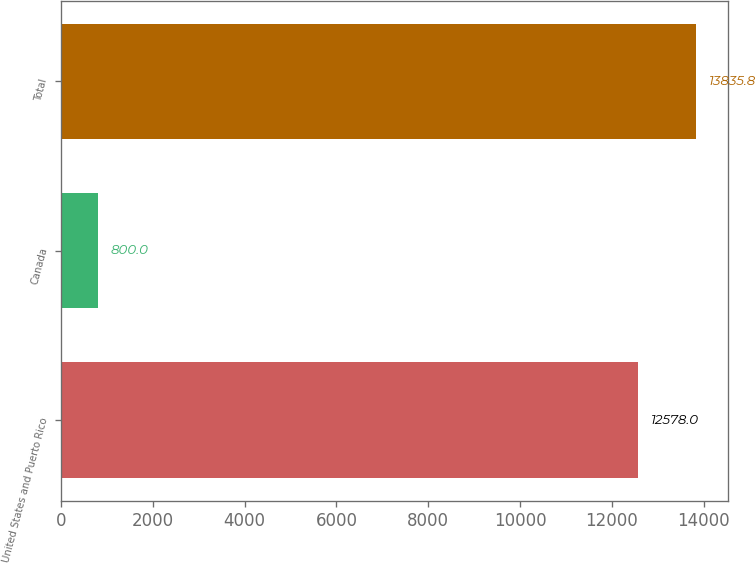Convert chart to OTSL. <chart><loc_0><loc_0><loc_500><loc_500><bar_chart><fcel>United States and Puerto Rico<fcel>Canada<fcel>Total<nl><fcel>12578<fcel>800<fcel>13835.8<nl></chart> 